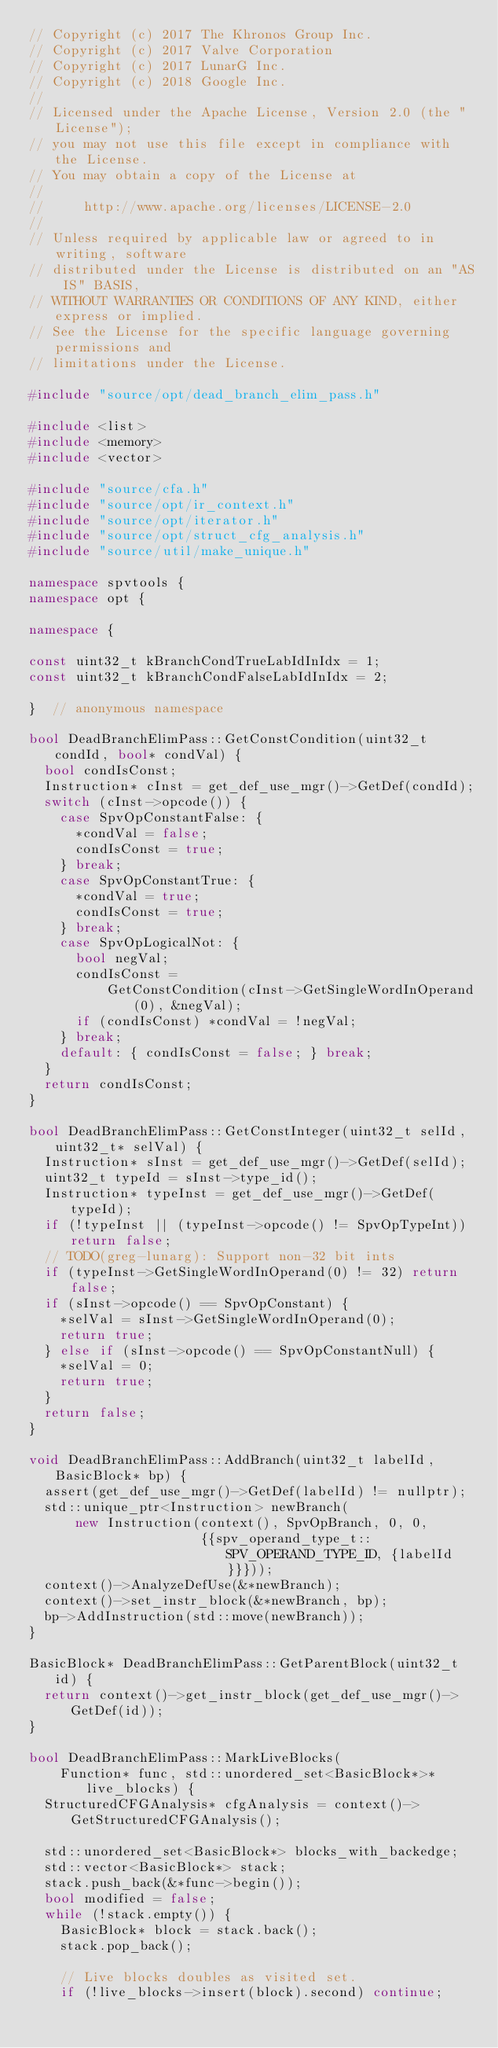Convert code to text. <code><loc_0><loc_0><loc_500><loc_500><_C++_>// Copyright (c) 2017 The Khronos Group Inc.
// Copyright (c) 2017 Valve Corporation
// Copyright (c) 2017 LunarG Inc.
// Copyright (c) 2018 Google Inc.
//
// Licensed under the Apache License, Version 2.0 (the "License");
// you may not use this file except in compliance with the License.
// You may obtain a copy of the License at
//
//     http://www.apache.org/licenses/LICENSE-2.0
//
// Unless required by applicable law or agreed to in writing, software
// distributed under the License is distributed on an "AS IS" BASIS,
// WITHOUT WARRANTIES OR CONDITIONS OF ANY KIND, either express or implied.
// See the License for the specific language governing permissions and
// limitations under the License.

#include "source/opt/dead_branch_elim_pass.h"

#include <list>
#include <memory>
#include <vector>

#include "source/cfa.h"
#include "source/opt/ir_context.h"
#include "source/opt/iterator.h"
#include "source/opt/struct_cfg_analysis.h"
#include "source/util/make_unique.h"

namespace spvtools {
namespace opt {

namespace {

const uint32_t kBranchCondTrueLabIdInIdx = 1;
const uint32_t kBranchCondFalseLabIdInIdx = 2;

}  // anonymous namespace

bool DeadBranchElimPass::GetConstCondition(uint32_t condId, bool* condVal) {
  bool condIsConst;
  Instruction* cInst = get_def_use_mgr()->GetDef(condId);
  switch (cInst->opcode()) {
    case SpvOpConstantFalse: {
      *condVal = false;
      condIsConst = true;
    } break;
    case SpvOpConstantTrue: {
      *condVal = true;
      condIsConst = true;
    } break;
    case SpvOpLogicalNot: {
      bool negVal;
      condIsConst =
          GetConstCondition(cInst->GetSingleWordInOperand(0), &negVal);
      if (condIsConst) *condVal = !negVal;
    } break;
    default: { condIsConst = false; } break;
  }
  return condIsConst;
}

bool DeadBranchElimPass::GetConstInteger(uint32_t selId, uint32_t* selVal) {
  Instruction* sInst = get_def_use_mgr()->GetDef(selId);
  uint32_t typeId = sInst->type_id();
  Instruction* typeInst = get_def_use_mgr()->GetDef(typeId);
  if (!typeInst || (typeInst->opcode() != SpvOpTypeInt)) return false;
  // TODO(greg-lunarg): Support non-32 bit ints
  if (typeInst->GetSingleWordInOperand(0) != 32) return false;
  if (sInst->opcode() == SpvOpConstant) {
    *selVal = sInst->GetSingleWordInOperand(0);
    return true;
  } else if (sInst->opcode() == SpvOpConstantNull) {
    *selVal = 0;
    return true;
  }
  return false;
}

void DeadBranchElimPass::AddBranch(uint32_t labelId, BasicBlock* bp) {
  assert(get_def_use_mgr()->GetDef(labelId) != nullptr);
  std::unique_ptr<Instruction> newBranch(
      new Instruction(context(), SpvOpBranch, 0, 0,
                      {{spv_operand_type_t::SPV_OPERAND_TYPE_ID, {labelId}}}));
  context()->AnalyzeDefUse(&*newBranch);
  context()->set_instr_block(&*newBranch, bp);
  bp->AddInstruction(std::move(newBranch));
}

BasicBlock* DeadBranchElimPass::GetParentBlock(uint32_t id) {
  return context()->get_instr_block(get_def_use_mgr()->GetDef(id));
}

bool DeadBranchElimPass::MarkLiveBlocks(
    Function* func, std::unordered_set<BasicBlock*>* live_blocks) {
  StructuredCFGAnalysis* cfgAnalysis = context()->GetStructuredCFGAnalysis();

  std::unordered_set<BasicBlock*> blocks_with_backedge;
  std::vector<BasicBlock*> stack;
  stack.push_back(&*func->begin());
  bool modified = false;
  while (!stack.empty()) {
    BasicBlock* block = stack.back();
    stack.pop_back();

    // Live blocks doubles as visited set.
    if (!live_blocks->insert(block).second) continue;
</code> 